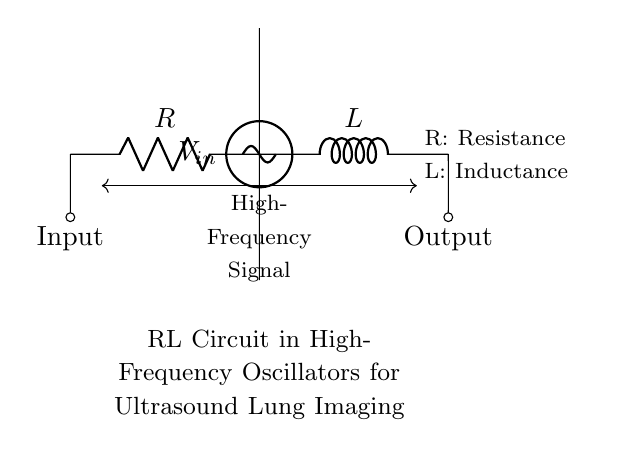What are the two components present in this circuit? The circuit diagram clearly shows a resistor and an inductor. These are the two main components depicted, with their labels R and L respectively.
Answer: Resistor, Inductor What is the input connection labeled as in the diagram? The input to the circuit is indicated by the label 'Input' at the connection point to the resistor. This signifies where the signal enters the circuit.
Answer: Input What type of circuit is represented in this diagram? The diagram represents an RL circuit, which consists of a resistor and an inductor in series. This specific configuration is used in various applications including high-frequency oscillators.
Answer: RL circuit What is the function of the inductor in this high-frequency circuit? The inductor in the circuit serves to store energy in a magnetic field when current flows through it. It is essential in filtering and resonance applications, especially at high frequencies relevant to ultrasound imaging.
Answer: Store energy How does the impedance change with frequency in an RL circuit? In an RL circuit, the impedance increases with frequency due to the inductive reactance component, which is directly proportional to the frequency. This results in higher impedance at higher frequencies, affecting current flow.
Answer: Increases with frequency What is the role of the resistor in this circuit? The resistor limits the current flow in the circuit, providing a controlled path for the electrical signal. It also dissipates energy as heat, which is important for thermal management in oscillators.
Answer: Limits current 